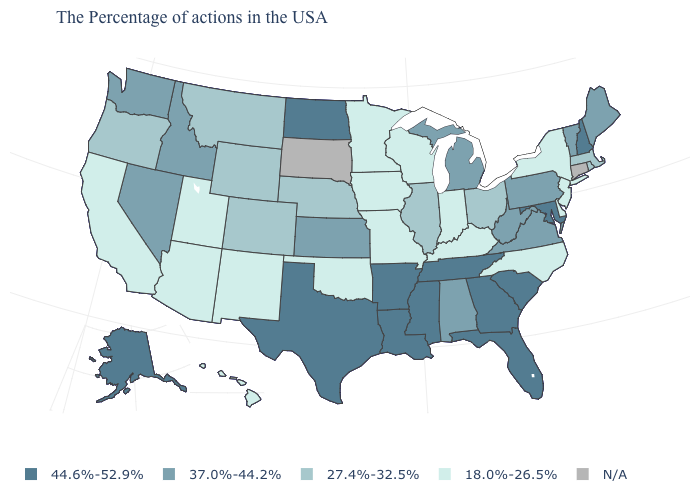Name the states that have a value in the range 37.0%-44.2%?
Short answer required. Maine, Vermont, Pennsylvania, Virginia, West Virginia, Michigan, Alabama, Kansas, Idaho, Nevada, Washington. What is the value of Tennessee?
Quick response, please. 44.6%-52.9%. What is the value of South Carolina?
Quick response, please. 44.6%-52.9%. What is the value of Arkansas?
Be succinct. 44.6%-52.9%. Does Missouri have the lowest value in the USA?
Answer briefly. Yes. Which states hav the highest value in the Northeast?
Be succinct. New Hampshire. Name the states that have a value in the range N/A?
Give a very brief answer. Connecticut, South Dakota. What is the lowest value in the South?
Give a very brief answer. 18.0%-26.5%. What is the value of Mississippi?
Keep it brief. 44.6%-52.9%. Which states hav the highest value in the MidWest?
Keep it brief. North Dakota. Does the first symbol in the legend represent the smallest category?
Write a very short answer. No. What is the value of Ohio?
Give a very brief answer. 27.4%-32.5%. Which states have the lowest value in the West?
Write a very short answer. New Mexico, Utah, Arizona, California, Hawaii. Name the states that have a value in the range 44.6%-52.9%?
Answer briefly. New Hampshire, Maryland, South Carolina, Florida, Georgia, Tennessee, Mississippi, Louisiana, Arkansas, Texas, North Dakota, Alaska. 